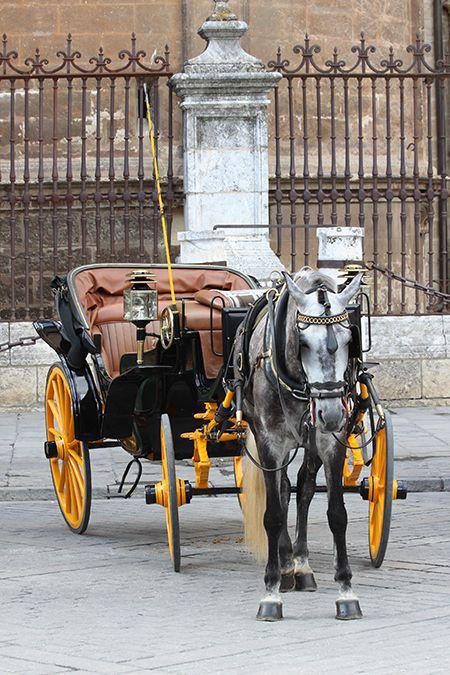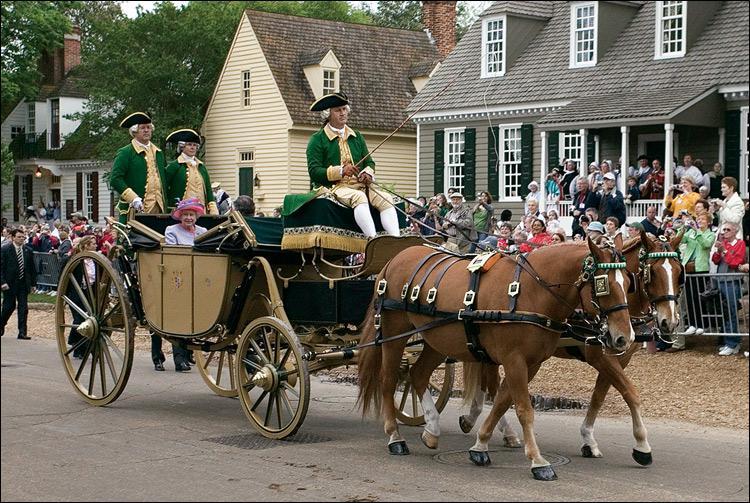The first image is the image on the left, the second image is the image on the right. For the images shown, is this caption "Teams of two horses are pulling the carriages." true? Answer yes or no. Yes. The first image is the image on the left, the second image is the image on the right. Analyze the images presented: Is the assertion "An image shows a four-wheeled wagon pulled by more than one horse." valid? Answer yes or no. Yes. 